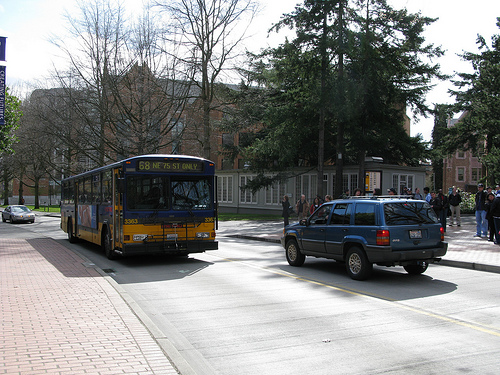What do the buildings in the background tell us about the location? The architecture of the buildings, which look like they could be a part of a university campus or institutional structures, suggest that this scene may be set in an educational or corporate environment. 